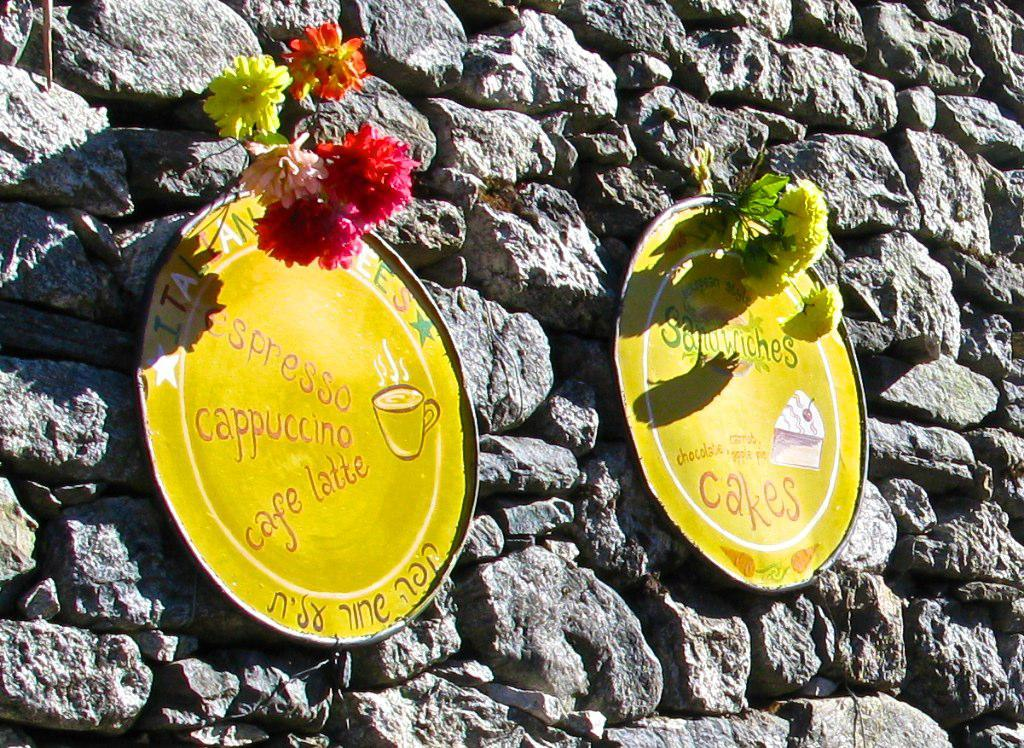What is attached to the stone wall in the image? There are two yellow color boards on the stone wall. What type of natural elements can be seen in the image? There are flowers in the image. What colors are present in the flowers? The flowers have yellow, red, pink, and orange colors. How does the process of joining the two yellow color boards occur in the image? There is no information about the process of joining the two yellow color boards in the image. Is there a gate visible in the image? There is no mention of a gate in the provided facts, so it cannot be determined if one is present in the image. 